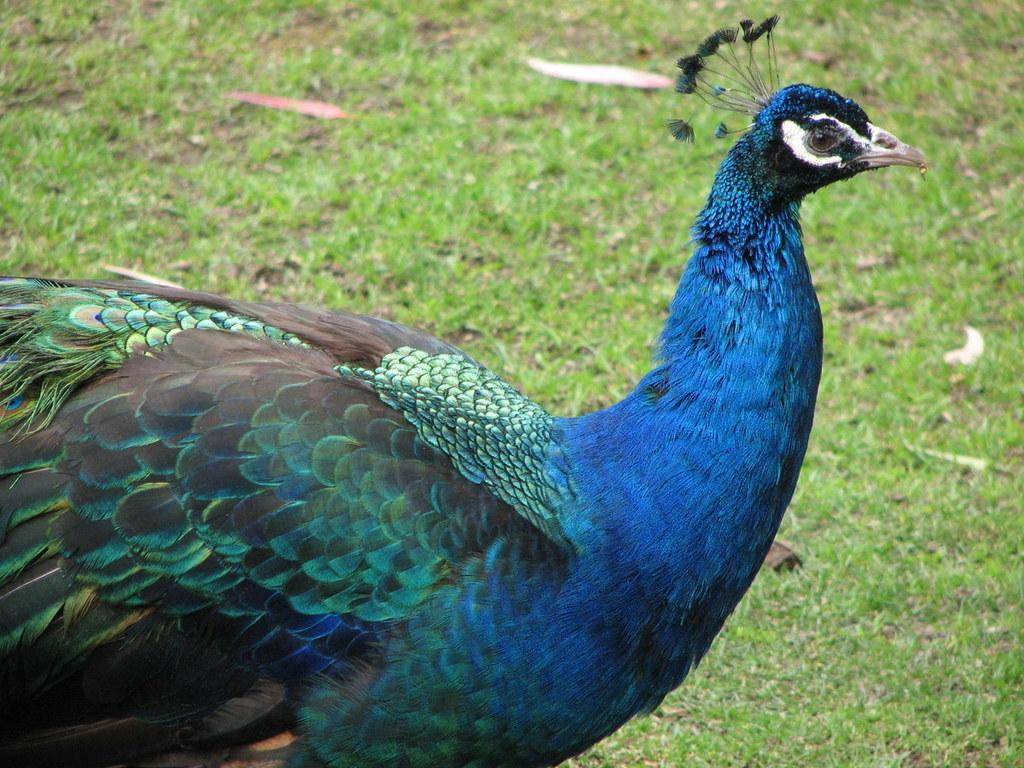What type of bird is in the image? There is a peacock in the image. What type of vegetation can be seen in the background of the image? There is grass visible in the background of the image. What type of cord is the peacock using to pull the grass in the image? There is no cord or pulling action depicted in the image; the peacock is simply standing in the grass. 